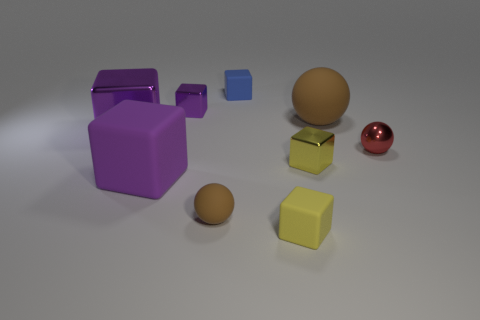What size is the other rubber sphere that is the same color as the tiny rubber sphere? The other rubber sphere that shares the same color as the tiny rubber sphere is large. It is visually discernible as much larger than the small sphere, yet their colors appear to match, signifying that they are indeed the same shade. 